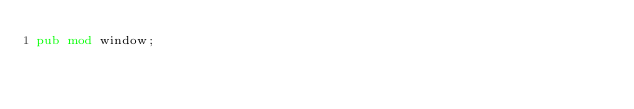Convert code to text. <code><loc_0><loc_0><loc_500><loc_500><_Rust_>pub mod window;
</code> 